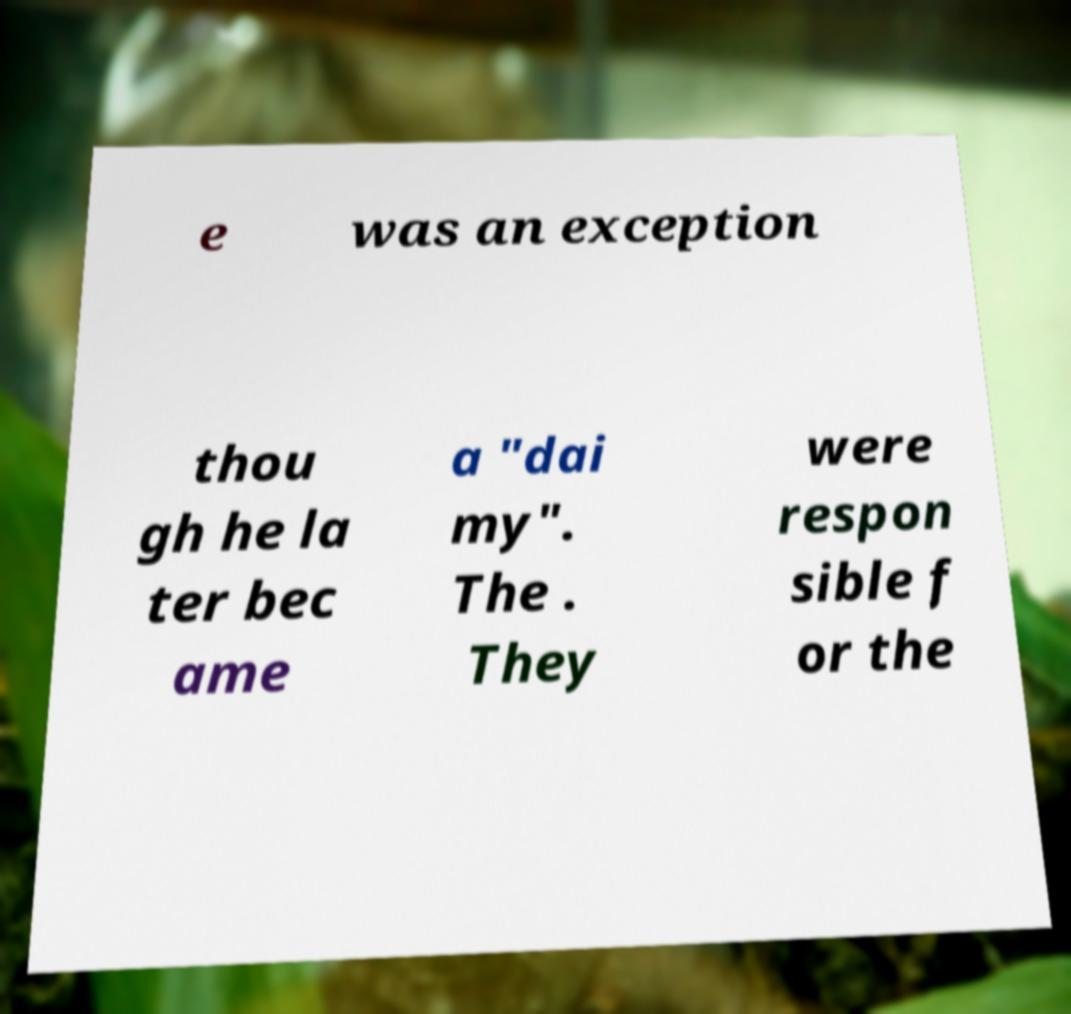There's text embedded in this image that I need extracted. Can you transcribe it verbatim? e was an exception thou gh he la ter bec ame a "dai my". The . They were respon sible f or the 